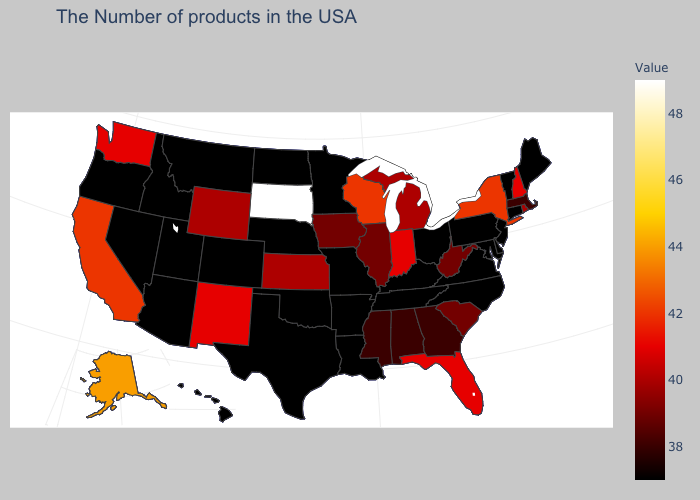Does South Dakota have the highest value in the USA?
Short answer required. Yes. Does the map have missing data?
Give a very brief answer. No. Is the legend a continuous bar?
Short answer required. Yes. Among the states that border Colorado , does Kansas have the lowest value?
Concise answer only. No. Among the states that border Arkansas , which have the lowest value?
Concise answer only. Tennessee, Louisiana, Missouri, Oklahoma, Texas. Among the states that border Nevada , does Idaho have the highest value?
Be succinct. No. Among the states that border Vermont , which have the lowest value?
Answer briefly. Massachusetts. Is the legend a continuous bar?
Be succinct. Yes. 